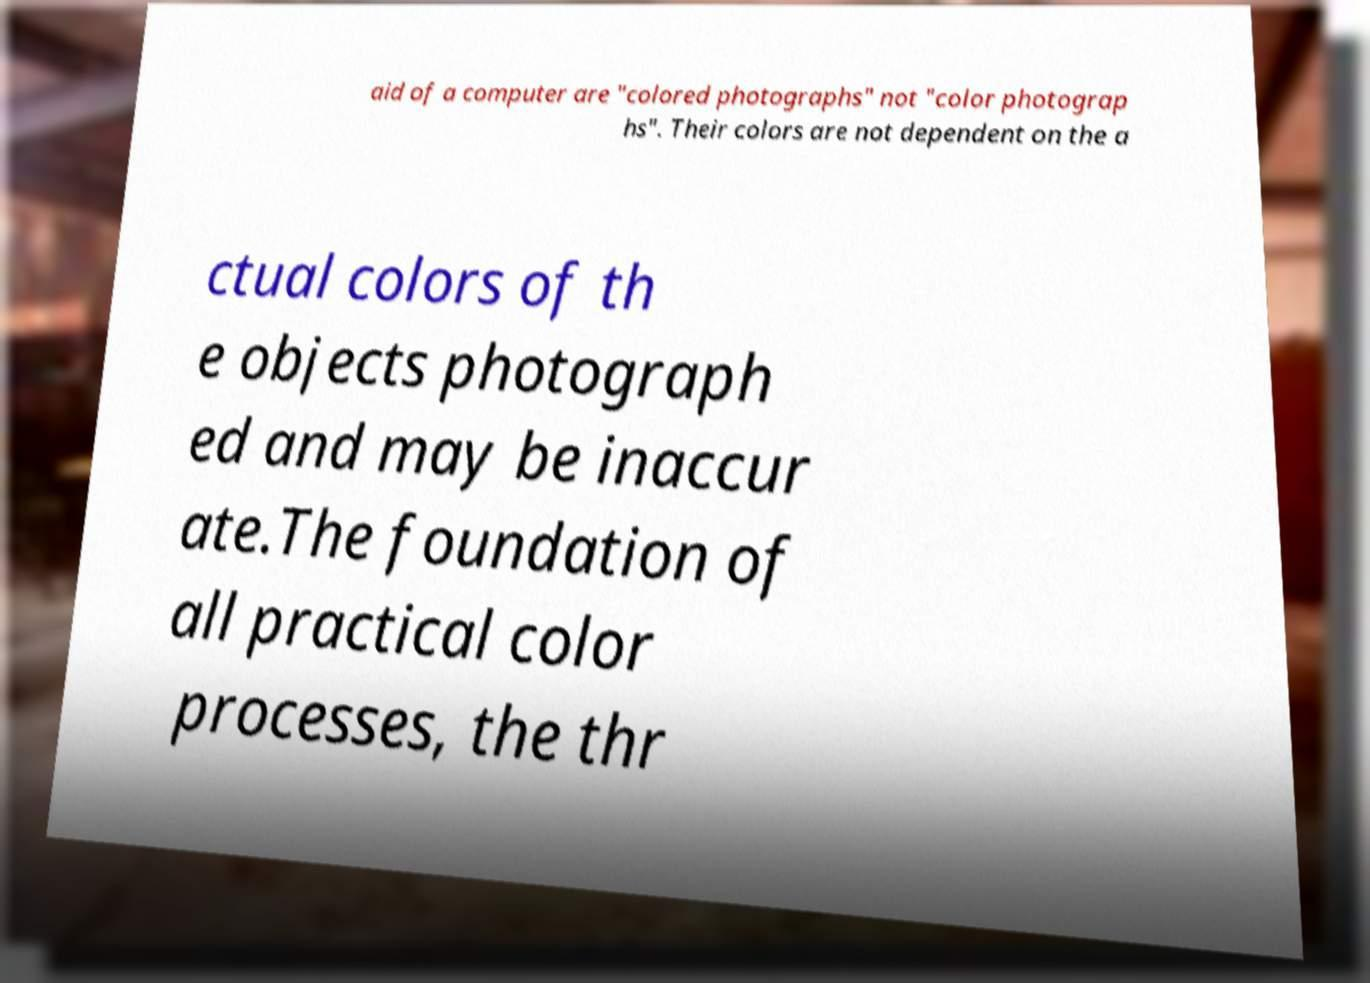There's text embedded in this image that I need extracted. Can you transcribe it verbatim? aid of a computer are "colored photographs" not "color photograp hs". Their colors are not dependent on the a ctual colors of th e objects photograph ed and may be inaccur ate.The foundation of all practical color processes, the thr 